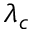<formula> <loc_0><loc_0><loc_500><loc_500>\lambda _ { c }</formula> 